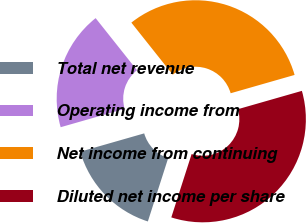Convert chart. <chart><loc_0><loc_0><loc_500><loc_500><pie_chart><fcel>Total net revenue<fcel>Operating income from<fcel>Net income from continuing<fcel>Diluted net income per share<nl><fcel>15.62%<fcel>18.75%<fcel>31.25%<fcel>34.38%<nl></chart> 